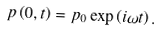<formula> <loc_0><loc_0><loc_500><loc_500>p \left ( 0 , t \right ) = p _ { 0 } \exp \left ( i \omega t \right ) .</formula> 